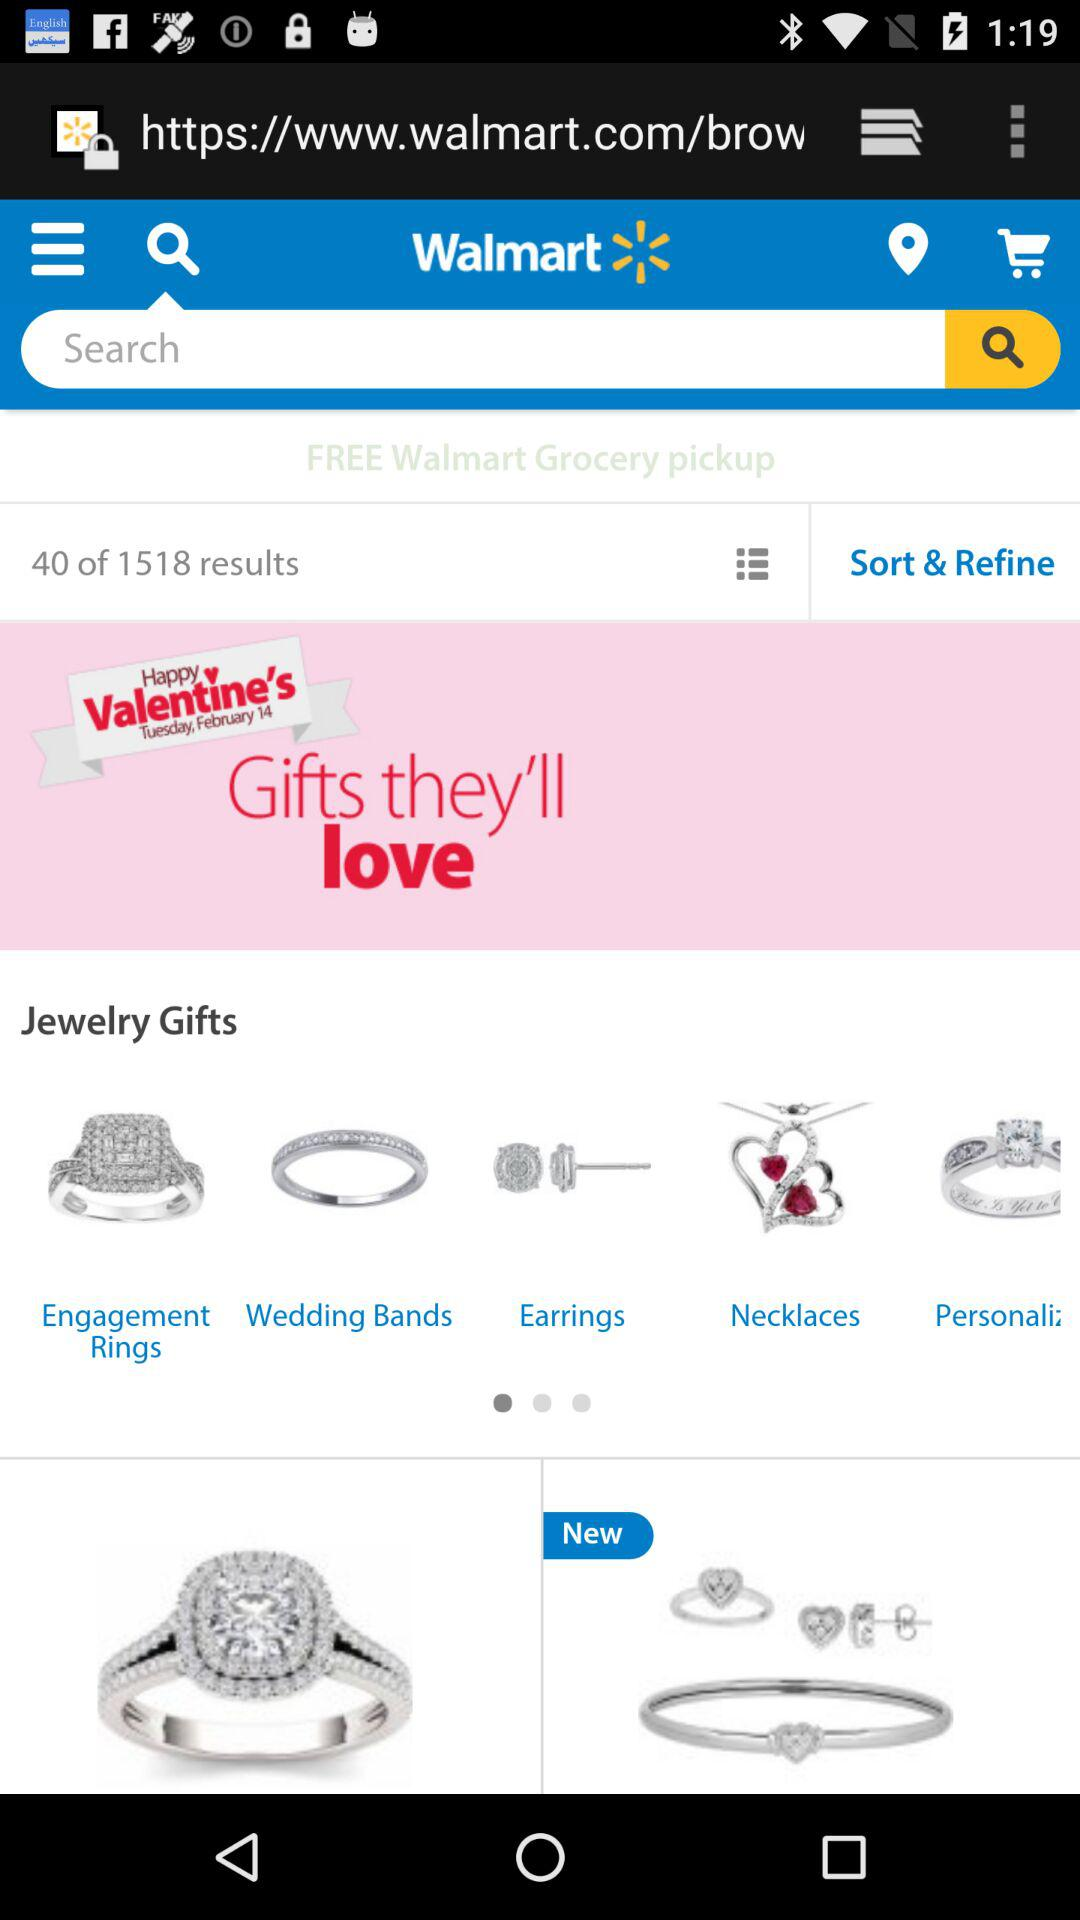How many items are in the jewelry gifts category?
Answer the question using a single word or phrase. 5 